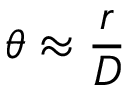<formula> <loc_0><loc_0><loc_500><loc_500>\theta \approx { \frac { r } { D } }</formula> 